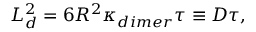Convert formula to latex. <formula><loc_0><loc_0><loc_500><loc_500>L _ { d } ^ { 2 } = 6 R ^ { 2 } \kappa _ { d i m e r } \tau \equiv D \tau ,</formula> 